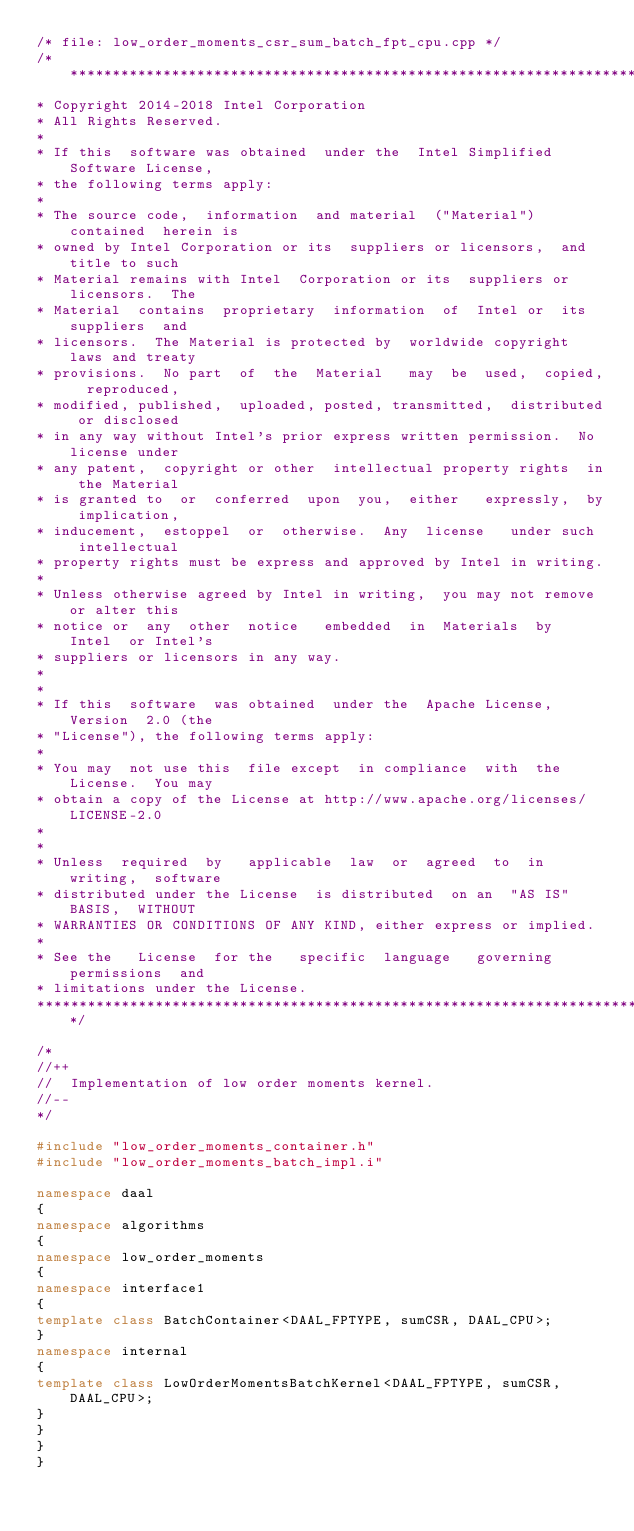<code> <loc_0><loc_0><loc_500><loc_500><_C++_>/* file: low_order_moments_csr_sum_batch_fpt_cpu.cpp */
/*******************************************************************************
* Copyright 2014-2018 Intel Corporation
* All Rights Reserved.
*
* If this  software was obtained  under the  Intel Simplified  Software License,
* the following terms apply:
*
* The source code,  information  and material  ("Material") contained  herein is
* owned by Intel Corporation or its  suppliers or licensors,  and  title to such
* Material remains with Intel  Corporation or its  suppliers or  licensors.  The
* Material  contains  proprietary  information  of  Intel or  its suppliers  and
* licensors.  The Material is protected by  worldwide copyright  laws and treaty
* provisions.  No part  of  the  Material   may  be  used,  copied,  reproduced,
* modified, published,  uploaded, posted, transmitted,  distributed or disclosed
* in any way without Intel's prior express written permission.  No license under
* any patent,  copyright or other  intellectual property rights  in the Material
* is granted to  or  conferred  upon  you,  either   expressly,  by implication,
* inducement,  estoppel  or  otherwise.  Any  license   under such  intellectual
* property rights must be express and approved by Intel in writing.
*
* Unless otherwise agreed by Intel in writing,  you may not remove or alter this
* notice or  any  other  notice   embedded  in  Materials  by  Intel  or Intel's
* suppliers or licensors in any way.
*
*
* If this  software  was obtained  under the  Apache License,  Version  2.0 (the
* "License"), the following terms apply:
*
* You may  not use this  file except  in compliance  with  the License.  You may
* obtain a copy of the License at http://www.apache.org/licenses/LICENSE-2.0
*
*
* Unless  required  by   applicable  law  or  agreed  to  in  writing,  software
* distributed under the License  is distributed  on an  "AS IS"  BASIS,  WITHOUT
* WARRANTIES OR CONDITIONS OF ANY KIND, either express or implied.
*
* See the   License  for the   specific  language   governing   permissions  and
* limitations under the License.
*******************************************************************************/

/*
//++
//  Implementation of low order moments kernel.
//--
*/

#include "low_order_moments_container.h"
#include "low_order_moments_batch_impl.i"

namespace daal
{
namespace algorithms
{
namespace low_order_moments
{
namespace interface1
{
template class BatchContainer<DAAL_FPTYPE, sumCSR, DAAL_CPU>;
}
namespace internal
{
template class LowOrderMomentsBatchKernel<DAAL_FPTYPE, sumCSR, DAAL_CPU>;
}
}
}
}
</code> 